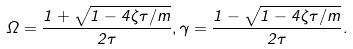Convert formula to latex. <formula><loc_0><loc_0><loc_500><loc_500>\Omega = \frac { 1 + \sqrt { 1 - 4 \zeta \tau / m } } { 2 \tau } , \gamma = \frac { 1 - \sqrt { 1 - 4 \zeta \tau / m } } { 2 \tau } .</formula> 